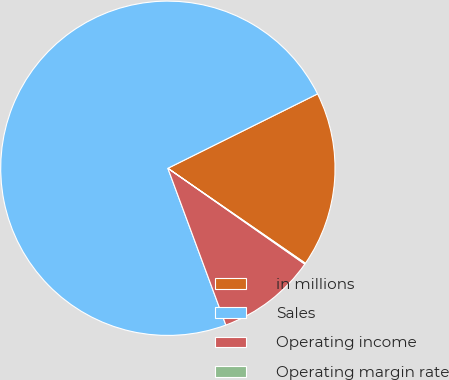<chart> <loc_0><loc_0><loc_500><loc_500><pie_chart><fcel>in millions<fcel>Sales<fcel>Operating income<fcel>Operating margin rate<nl><fcel>16.96%<fcel>73.3%<fcel>9.64%<fcel>0.1%<nl></chart> 